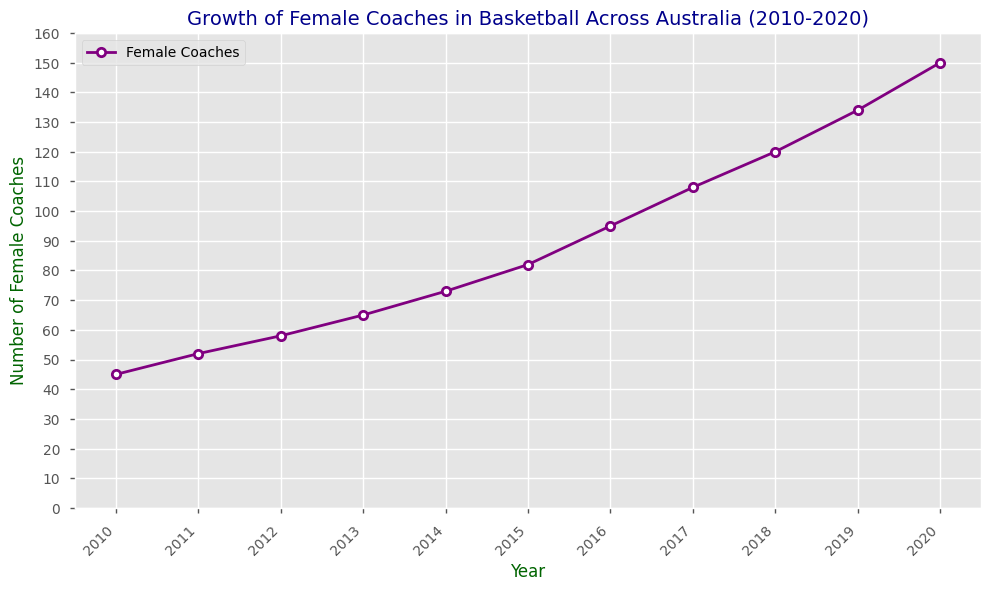What is the overall trend of the number of female coaches from 2010 to 2020? By looking at the line plot, the number of female coaches increases steadily from 2010 to 2020, indicating a positive growth trend over the years.
Answer: Increasing How many female coaches were added between 2010 and 2015? By subtracting the number of female coaches in 2010 (45) from the number in 2015 (82), we get 82 - 45.
Answer: 37 In which year did the number of female coaches surpass 100? Looking at the number of female coaches each year, in 2017 the number reached 108, surpassing 100 for the first time.
Answer: 2017 What is the range of the number of female coaches between 2010 and 2020? The range is the difference between the maximum and minimum values. The maximum number of female coaches is 150 in 2020, and the minimum is 45 in 2010. So, 150 - 45.
Answer: 105 What was the average yearly increase in the number of female coaches from 2010 to 2020? The total increase from 2010 to 2020 is 150 - 45 = 105. Dividing this by the number of years (2020 - 2010), we get an average yearly increase of 105 / 10.
Answer: 10.5 Did the number of female coaches increase more rapidly between 2010 to 2015 or 2015 to 2020? From 2010 to 2015, the increase is 82 - 45 = 37. From 2015 to 2020, it is 150 - 82 = 68. Therefore, the increase was more rapid between 2015 and 2020.
Answer: 2015 to 2020 What was the lowest number of female coaches in a year within the given data? By observing the plot, the lowest number of female coaches, which occurred in 2010, was 45.
Answer: 45 How did the number of female coaches change between 2016 and 2017? The number of female coaches increased from 95 in 2016 to 108 in 2017. Therefore, the change is 108 - 95.
Answer: 13 Which year saw the largest single-year increase in the number of female coaches? By comparing the differences year by year, the largest single-year increase occurred from 2016 to 2017, with an increase of 108 - 95 = 13.
Answer: 2017 Are there any years where the number of female coaches did not increase? By observing the consistent upward trend in the line plot from 2010 to 2020, there are no years where the number of female coaches did not increase.
Answer: No 